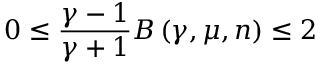<formula> <loc_0><loc_0><loc_500><loc_500>0 \leq \frac { \gamma - 1 } { \gamma + 1 } B \left ( \gamma , \mu , n \right ) \leq 2</formula> 